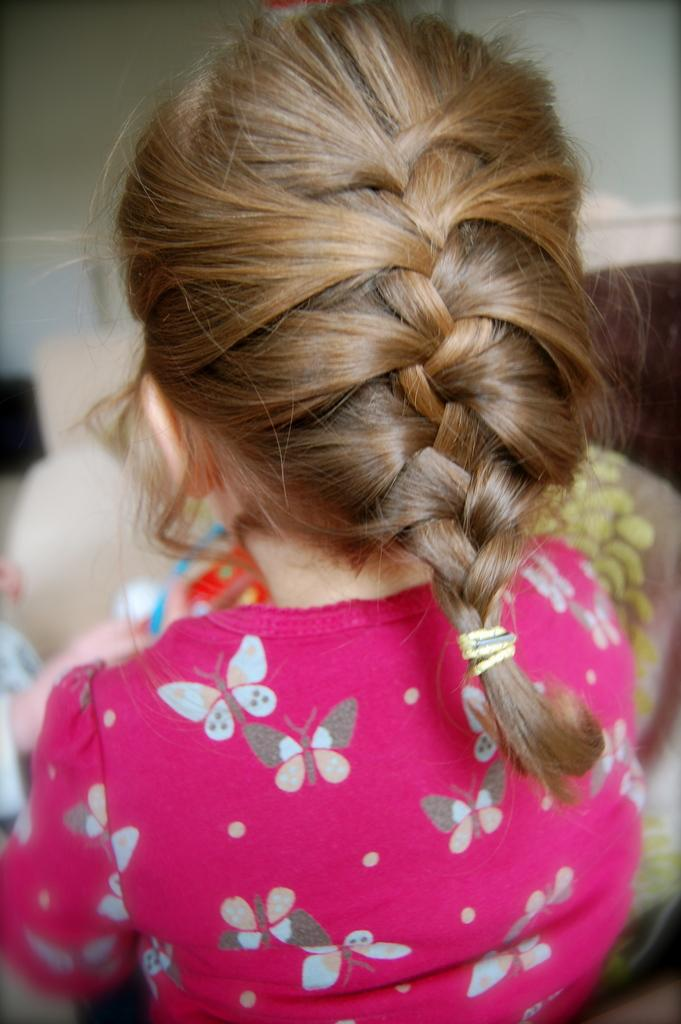Who is the main subject in the picture? There is a girl in the picture. What can be observed about the background of the image? The background of the image is blurred. What type of chair is the girl sitting on in the image? There is no chair present in the image; the girl is not sitting. 